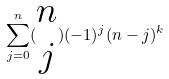<formula> <loc_0><loc_0><loc_500><loc_500>\sum _ { j = 0 } ^ { n } ( \begin{matrix} n \\ j \end{matrix} ) ( - 1 ) ^ { j } ( n - j ) ^ { k }</formula> 